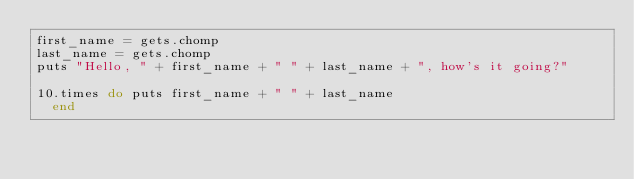<code> <loc_0><loc_0><loc_500><loc_500><_Ruby_>first_name = gets.chomp
last_name = gets.chomp
puts "Hello, " + first_name + " " + last_name + ", how's it going?"

10.times do puts first_name + " " + last_name
  end</code> 